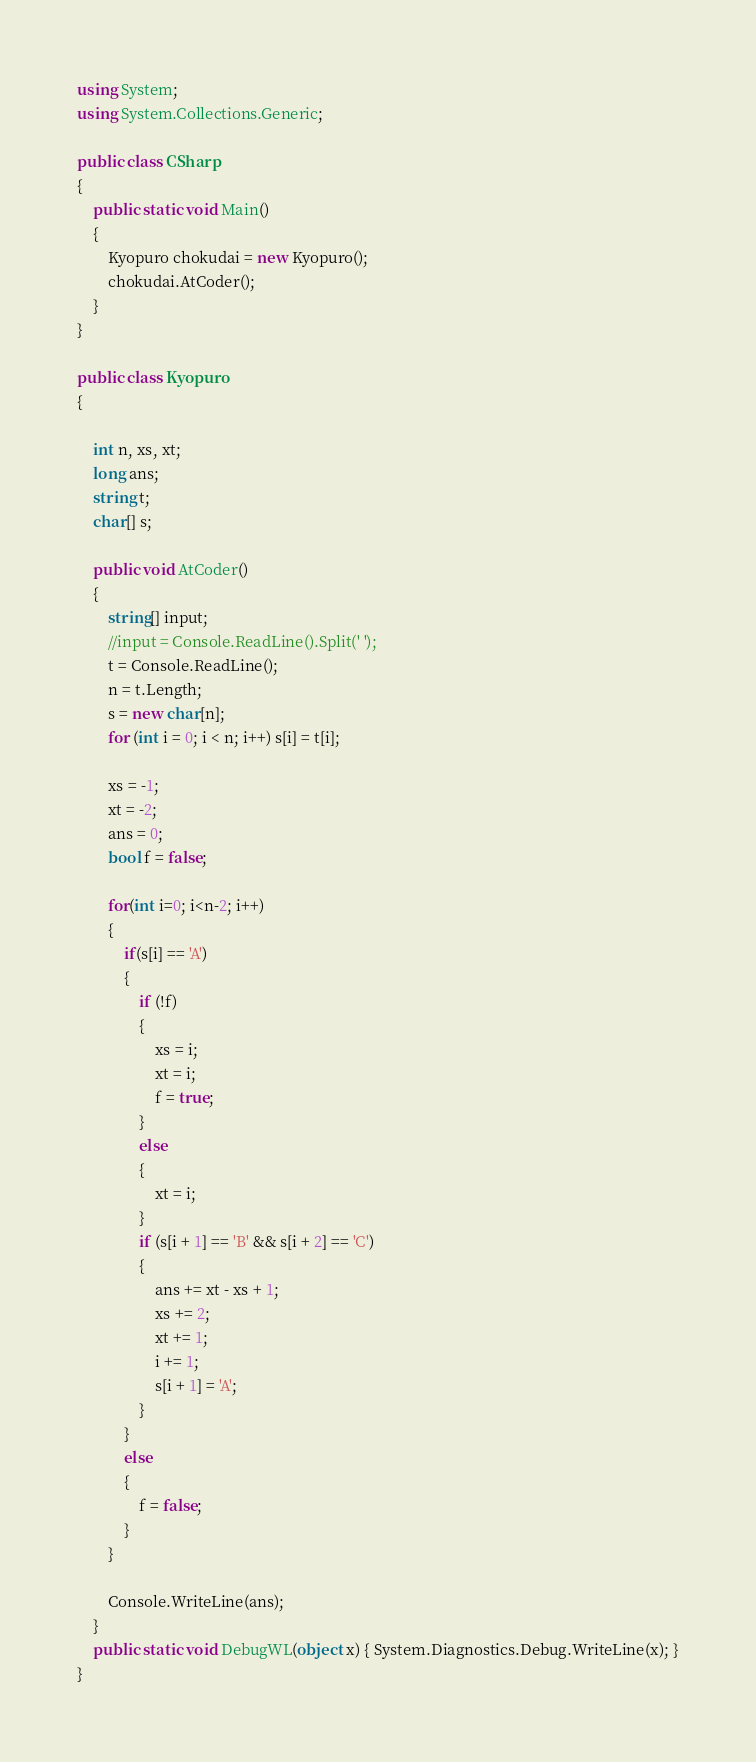<code> <loc_0><loc_0><loc_500><loc_500><_C#_>using System;
using System.Collections.Generic;

public class CSharp
{
    public static void Main()
    {
        Kyopuro chokudai = new Kyopuro();
        chokudai.AtCoder();
    }
}

public class Kyopuro
{

    int n, xs, xt;
    long ans;
    string t;
    char[] s;

    public void AtCoder()
    {
        string[] input;
        //input = Console.ReadLine().Split(' ');
        t = Console.ReadLine();
        n = t.Length;
        s = new char[n];
        for (int i = 0; i < n; i++) s[i] = t[i];

        xs = -1;
        xt = -2;
        ans = 0;
        bool f = false;

        for(int i=0; i<n-2; i++)
        {           
            if(s[i] == 'A')
            {
                if (!f)
                {
                    xs = i;
                    xt = i;
                    f = true;
                }
                else
                {
                    xt = i;
                }
                if (s[i + 1] == 'B' && s[i + 2] == 'C')
                {
                    ans += xt - xs + 1;
                    xs += 2;
                    xt += 1;
                    i += 1;
                    s[i + 1] = 'A';
                }
            }
            else
            {
                f = false;
            }
        }
        
        Console.WriteLine(ans);
    }
    public static void DebugWL(object x) { System.Diagnostics.Debug.WriteLine(x); }
}
</code> 